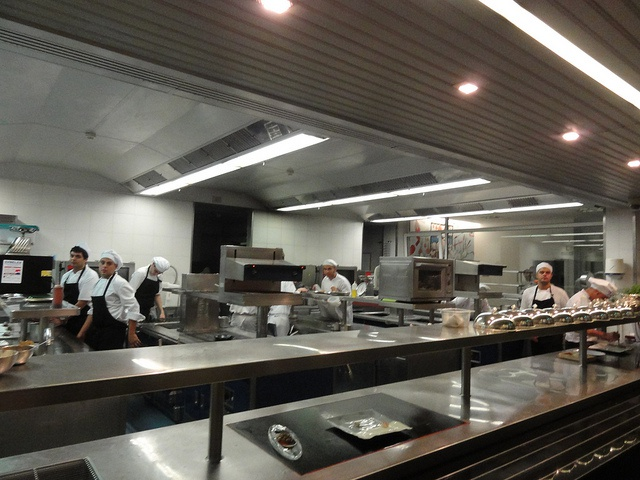Describe the objects in this image and their specific colors. I can see people in black, darkgray, gray, and lightgray tones, oven in black and gray tones, microwave in black and gray tones, people in black, darkgray, gray, and maroon tones, and people in black, darkgray, lightgray, and gray tones in this image. 